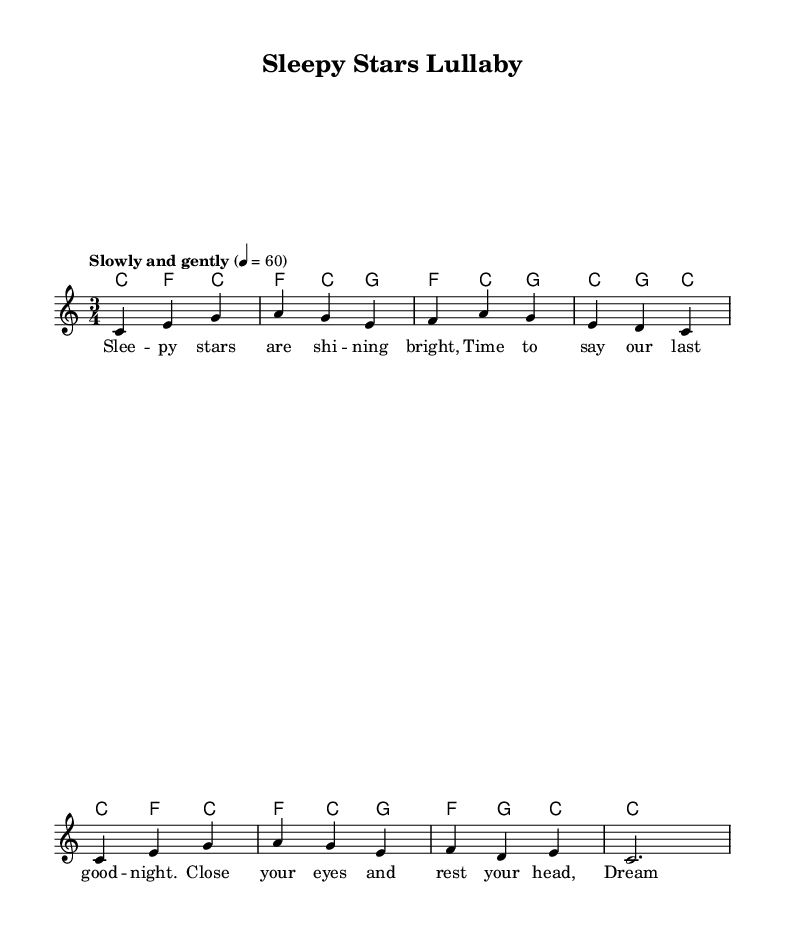What is the key signature of this music? The key signature is C major, which has no sharps or flats.
Answer: C major What is the time signature of this piece? The time signature is indicated as three beats per measure, which is shown as 3/4.
Answer: 3/4 What is the tempo marking for this lullaby? The tempo marking states "Slowly and gently," which indicates a slow pace for the piece.
Answer: Slowly and gently How many measures are there in the melody? Counting the measures in the melody section, there are a total of eight measures.
Answer: Eight What are the lyrics about? The lyrics convey a comforting message designed for children, speaking about sleeping and dreaming peacefully.
Answer: Sleeping and dreaming What is the last note played in the melody? The last note in the melody is a half note, which is "c" at the end of the last measure.
Answer: c Which musical element distinguishes this as a lullaby? The overall soothing characteristics of the melody, combined with the gentle lyrics, create a calming atmosphere typical for lullabies.
Answer: Soothing characteristics 